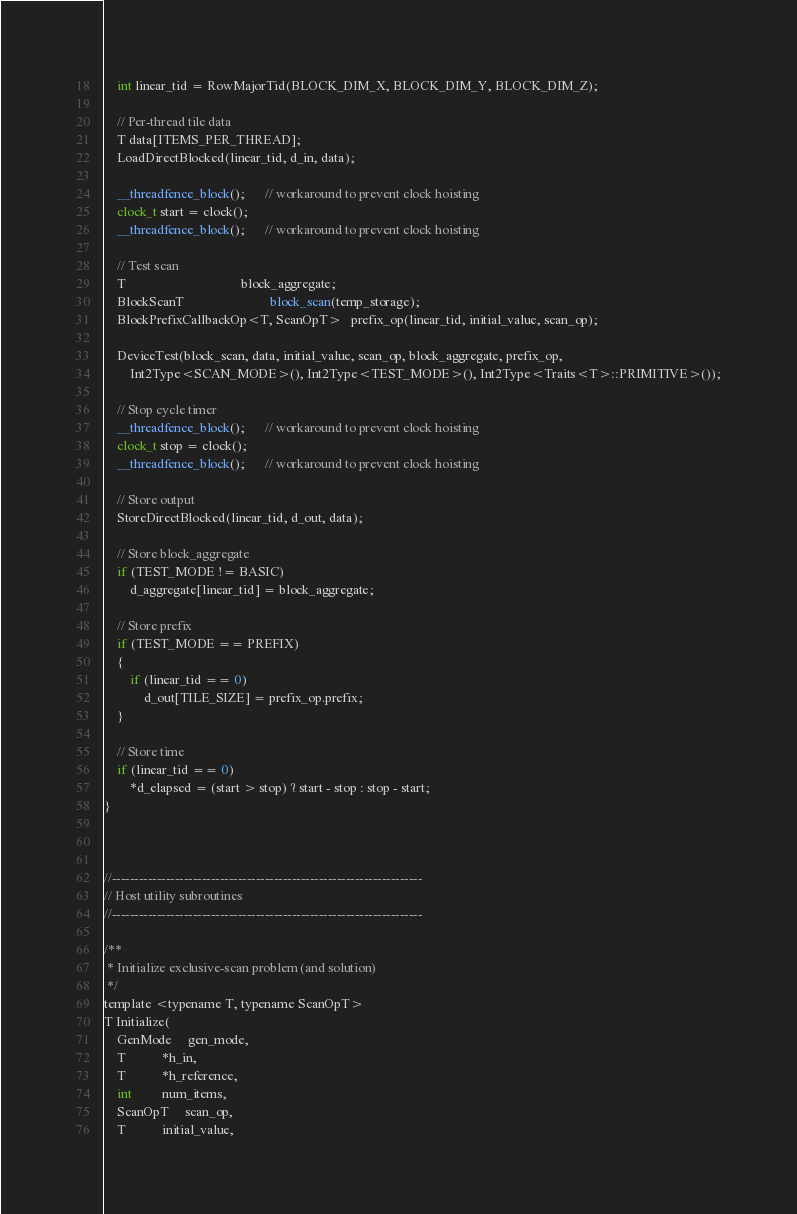<code> <loc_0><loc_0><loc_500><loc_500><_Cuda_>    int linear_tid = RowMajorTid(BLOCK_DIM_X, BLOCK_DIM_Y, BLOCK_DIM_Z);

    // Per-thread tile data
    T data[ITEMS_PER_THREAD];
    LoadDirectBlocked(linear_tid, d_in, data);

    __threadfence_block();      // workaround to prevent clock hoisting
    clock_t start = clock();
    __threadfence_block();      // workaround to prevent clock hoisting

    // Test scan
    T                                   block_aggregate;
    BlockScanT                          block_scan(temp_storage);
    BlockPrefixCallbackOp<T, ScanOpT>   prefix_op(linear_tid, initial_value, scan_op);

    DeviceTest(block_scan, data, initial_value, scan_op, block_aggregate, prefix_op,
        Int2Type<SCAN_MODE>(), Int2Type<TEST_MODE>(), Int2Type<Traits<T>::PRIMITIVE>());

    // Stop cycle timer
    __threadfence_block();      // workaround to prevent clock hoisting
    clock_t stop = clock();
    __threadfence_block();      // workaround to prevent clock hoisting

    // Store output
    StoreDirectBlocked(linear_tid, d_out, data);

    // Store block_aggregate
    if (TEST_MODE != BASIC)
        d_aggregate[linear_tid] = block_aggregate;

    // Store prefix
    if (TEST_MODE == PREFIX)
    {
        if (linear_tid == 0)
            d_out[TILE_SIZE] = prefix_op.prefix;
    }

    // Store time
    if (linear_tid == 0)
        *d_elapsed = (start > stop) ? start - stop : stop - start;
}



//---------------------------------------------------------------------
// Host utility subroutines
//---------------------------------------------------------------------

/**
 * Initialize exclusive-scan problem (and solution)
 */
template <typename T, typename ScanOpT>
T Initialize(
    GenMode     gen_mode,
    T           *h_in,
    T           *h_reference,
    int         num_items,
    ScanOpT     scan_op,
    T           initial_value,</code> 